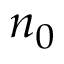<formula> <loc_0><loc_0><loc_500><loc_500>n _ { 0 }</formula> 